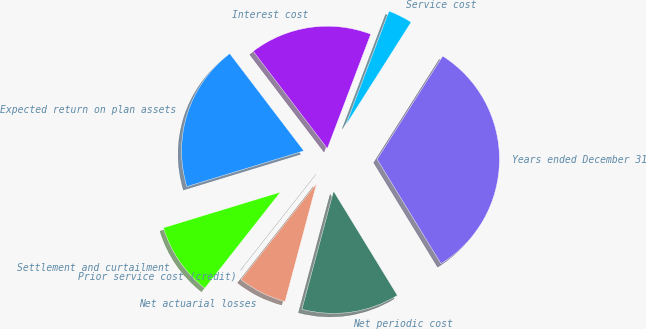Convert chart. <chart><loc_0><loc_0><loc_500><loc_500><pie_chart><fcel>Years ended December 31<fcel>Service cost<fcel>Interest cost<fcel>Expected return on plan assets<fcel>Settlement and curtailment<fcel>Prior service cost (credit)<fcel>Net actuarial losses<fcel>Net periodic cost<nl><fcel>32.26%<fcel>3.23%<fcel>16.13%<fcel>19.35%<fcel>9.68%<fcel>0.0%<fcel>6.45%<fcel>12.9%<nl></chart> 